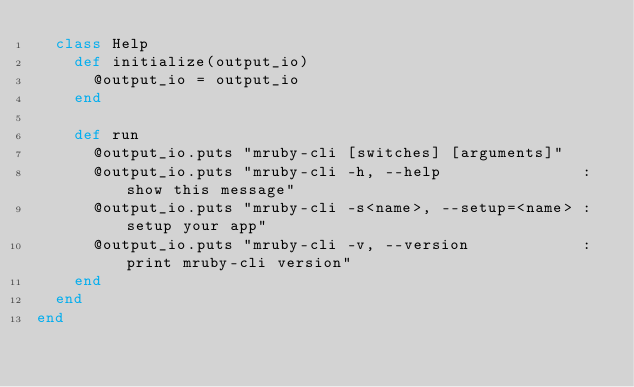<code> <loc_0><loc_0><loc_500><loc_500><_Ruby_>  class Help
    def initialize(output_io)
      @output_io = output_io
    end

    def run
      @output_io.puts "mruby-cli [switches] [arguments]"
      @output_io.puts "mruby-cli -h, --help               : show this message"
      @output_io.puts "mruby-cli -s<name>, --setup=<name> : setup your app"
      @output_io.puts "mruby-cli -v, --version            : print mruby-cli version"
    end
  end
end
</code> 